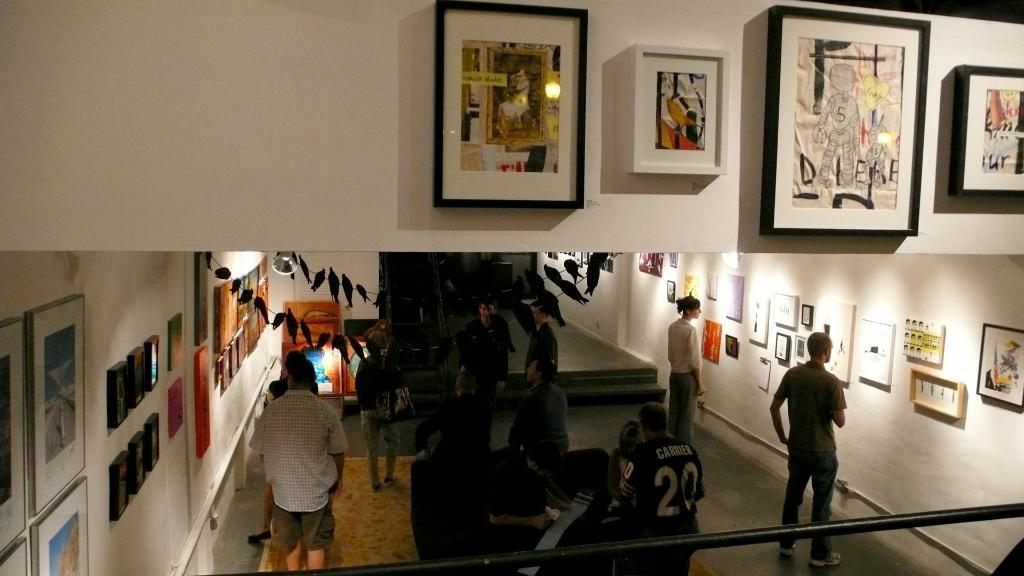What are the people in the image doing? The people in the image are standing on the ground. What can be seen on the wall in the image? There are photo frames on the wall in the image. Can you tell me how many friends are joining the people in the image? There is no information about friends joining the people in the image. What type of berry can be seen growing on the wall in the image? There are no berries present in the image; it only features people standing on the ground and photo frames on the wall. 